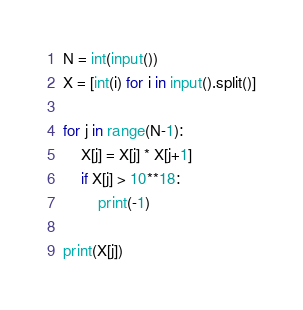<code> <loc_0><loc_0><loc_500><loc_500><_Python_>N = int(input())
X = [int(i) for i in input().split()]

for j in range(N-1):
    X[j] = X[j] * X[j+1]
    if X[j] > 10**18:
        print(-1)

print(X[j])</code> 